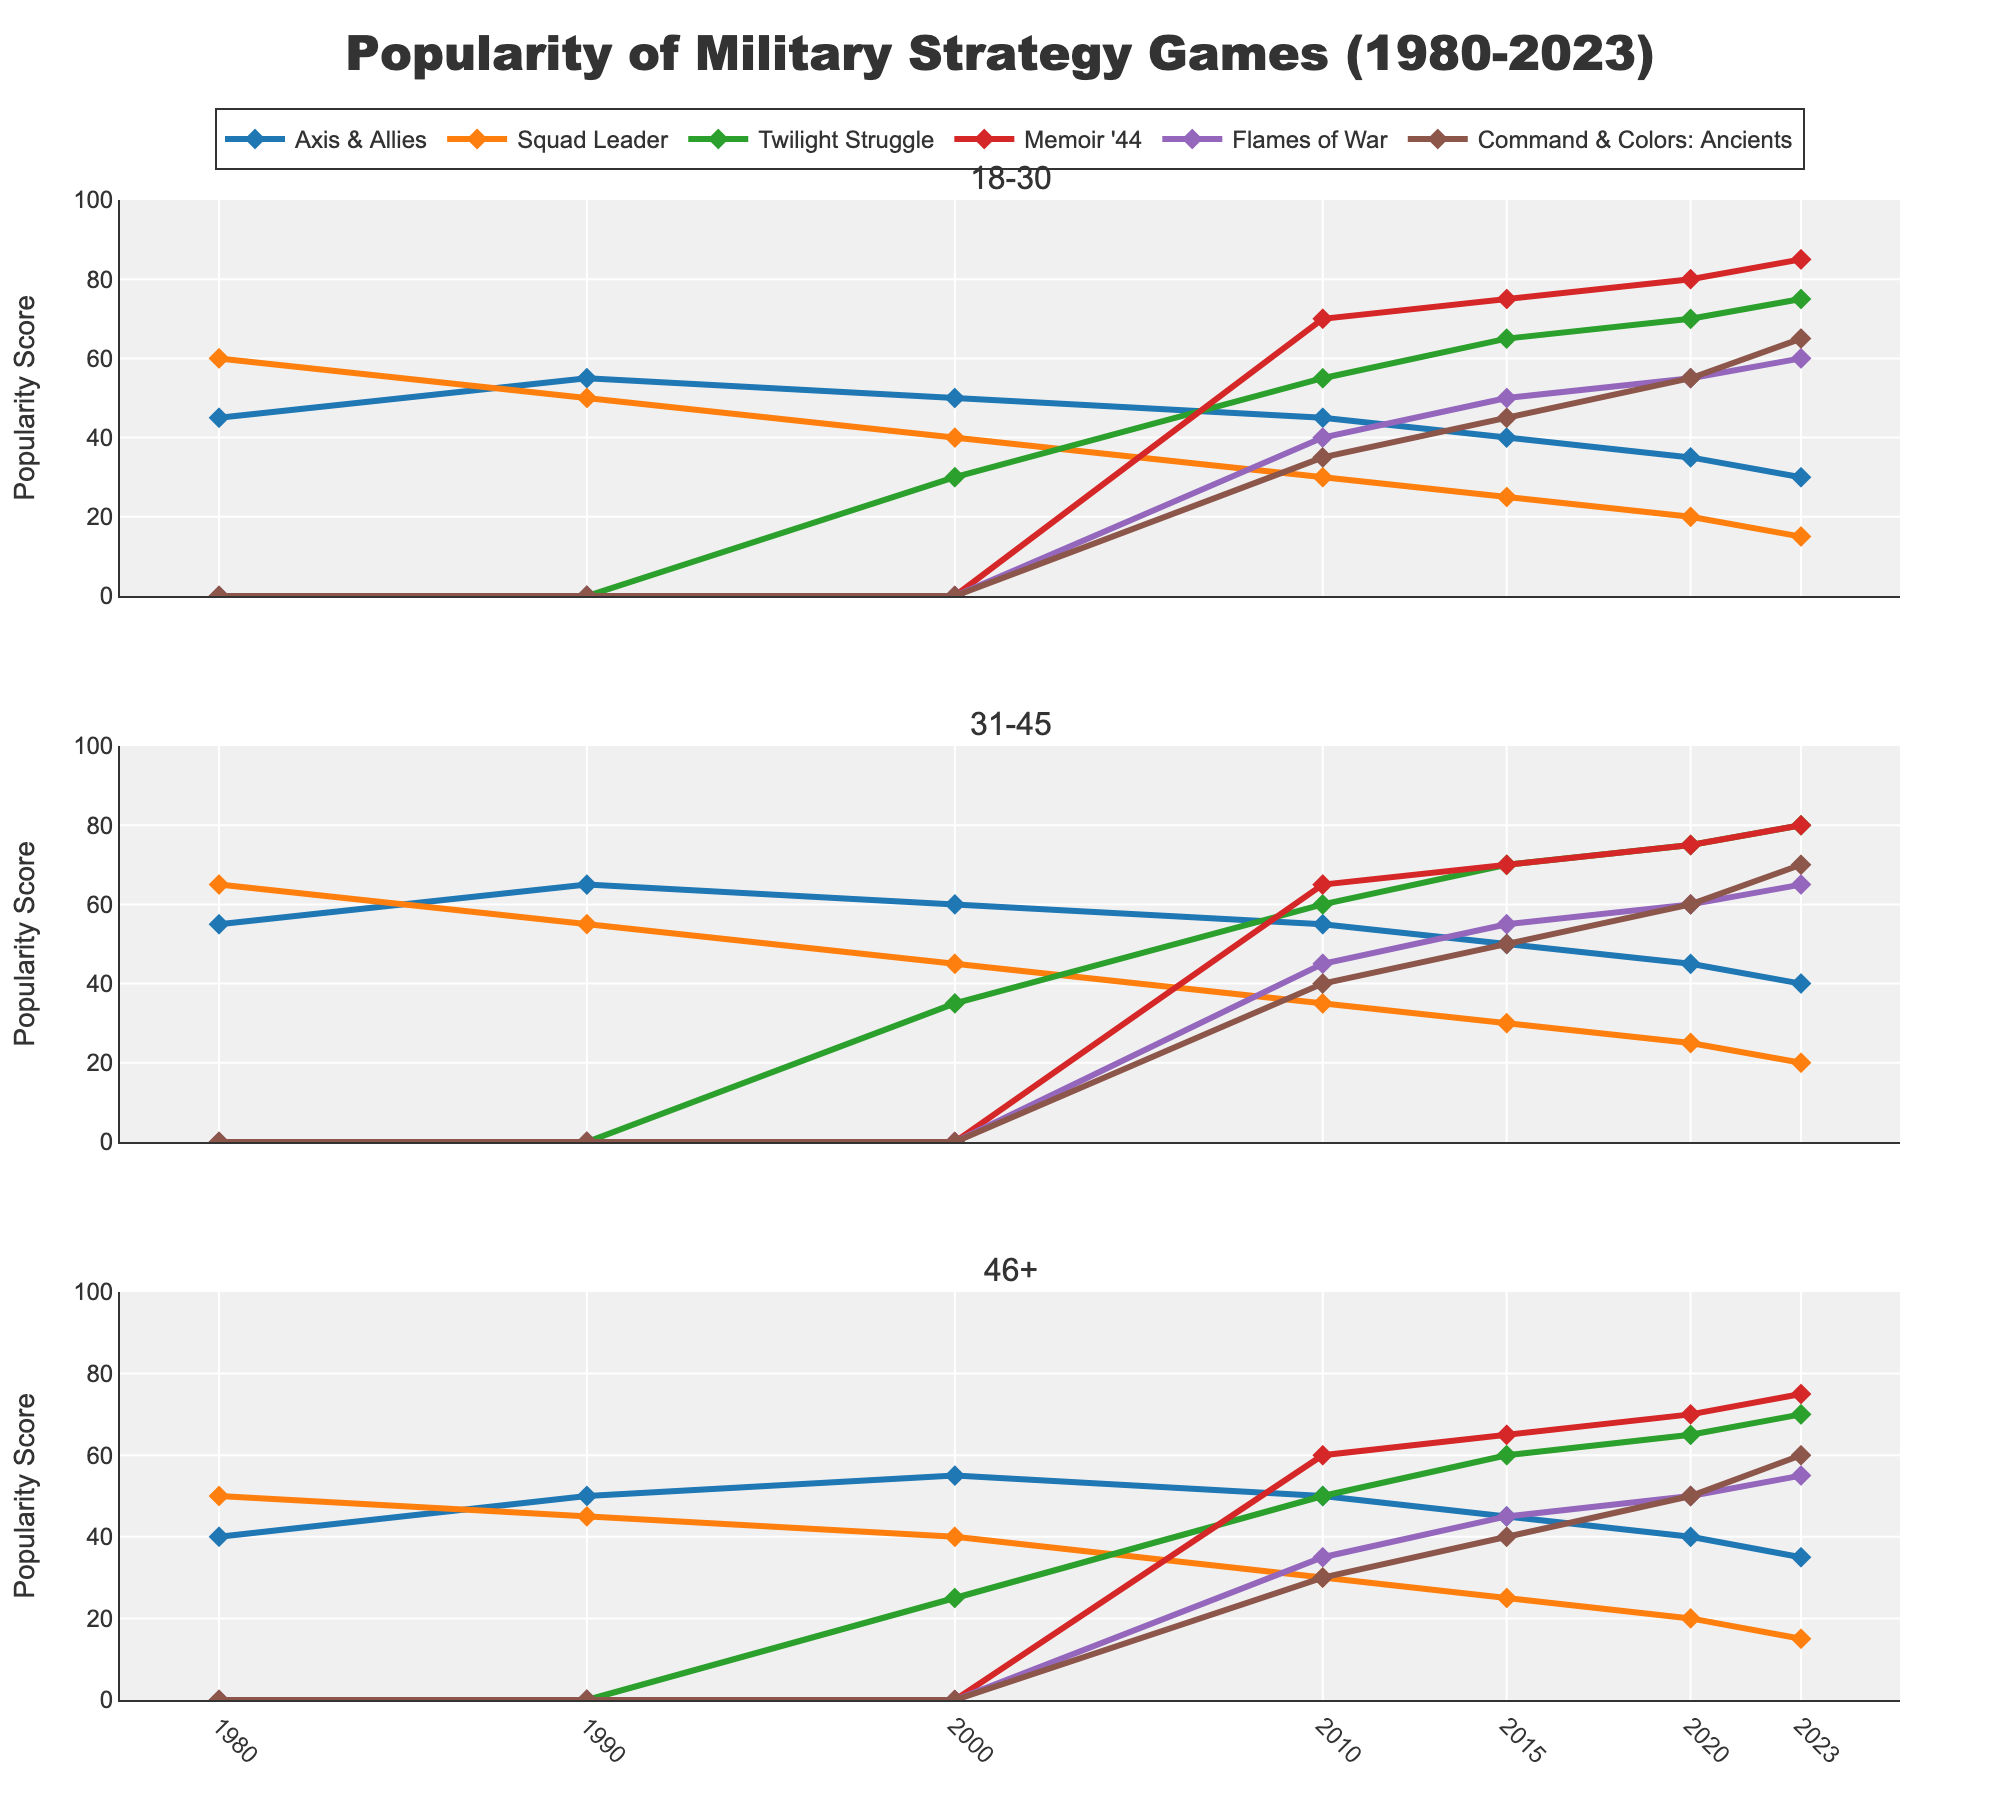How did the popularity of Axis & Allies change for the 18-30 age group from 1980 to 2023? The popularity of Axis & Allies started at 45 in 1980 and decreased to 30 by 2023. Therefore, the popularity declined by 15 points.
Answer: Declined by 15 points Which game had the highest popularity in the 46+ age group in 2020? In 2020, Memoir '44 had the highest popularity in the 46+ age group with a score of 70.
Answer: Memoir '44 Compare the popularity trend of Twilight Struggle for the 18-30 age group and the 31-45 age group from 2000 to 2023. For the 18-30 age group, Twilight Struggle increased from 30 in 2000 to 75 in 2023. For the 31-45 age group, it increased from 35 in 2000 to 80 in 2023. Both age groups showed an increasing trend, with the 31-45 age group having slightly higher popularity overall.
Answer: Both increased, 31-45 slightly higher What is the overall pattern in the popularity of Squad Leader across all age groups between 1980 and 2023? Squad Leader's popularity has declined in all age groups over the years. For example, in the 18-30 age group, the popularity decreased from 60 in 1980 to 15 in 2023.
Answer: Declined Which age group had the highest average popularity for Command & Colors: Ancients in 2023? The average popularity for Command & Colors: Ancients in 2023 is calculated as follows: (18-30: 65, 31-45: 70, 46+: 60). The 31-45 age group had the highest average popularity.
Answer: 31-45 Compare the popularity of Flames of War for the 18-30 age group in 2010 and 2020. In 2010, the popularity of Flames of War for the 18-30 age group was 40, and it increased to 55 by 2020, showing a growth of 15 points.
Answer: Increased by 15 points What is the difference between the peak popularity of Memoir '44 and Command & Colors: Ancients for the 46+ age group from 2010 to 2023? The peak popularity of Memoir '44 for the 46+ age group was 75 in 2023, and for Command & Colors: Ancients, it was 60 in 2023. The difference is 75 - 60 = 15.
Answer: 15 Identify the game with the smallest change in popularity for the 18-30 age group between 2015 and 2023. Axis & Allies changed from 40 to 30 (a decrease of 10), Squad Leader from 25 to 15 (a decrease of 10), Twilight Struggle from 65 to 75 (an increase of 10), Memoir '44 from 75 to 85 (an increase of 10), Flames of War from 50 to 60 (an increase of 10), and Command & Colors: Ancients from 45 to 65 (an increase of 20). All except Command & Colors: Ancients had a change of 10.
Answer: Axis & Allies, Squad Leader, Twilight Struggle, Memoir '44, Flames of War What was the average popularity of Memoir '44 across all age groups in 2010? In 2010, Memoir '44 had 70 for 18-30, 65 for 31-45, and 60 for 46+. The average is (70 + 65 + 60) / 3 = 65.
Answer: 65 Which age group saw the largest decrease in popularity for Axis & Allies between 2000 and 2023? The 18-30 age group saw a decrease from 50 in 2000 to 30 in 2023 (20 points), the 31-45 age group from 60 to 40 (20 points), and the 46+ age group from 55 to 35 (20 points). They all saw a decrease of 20 points.
Answer: All age groups 